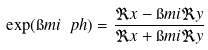<formula> <loc_0><loc_0><loc_500><loc_500>\exp ( \i m i \ p h ) = \frac { \Re x - \i m i \Re y } { \Re x + \i m i \Re y }</formula> 